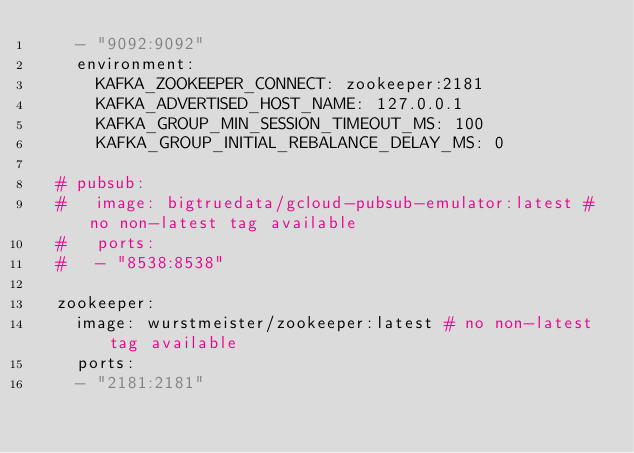Convert code to text. <code><loc_0><loc_0><loc_500><loc_500><_YAML_>    - "9092:9092"
    environment:
      KAFKA_ZOOKEEPER_CONNECT: zookeeper:2181
      KAFKA_ADVERTISED_HOST_NAME: 127.0.0.1
      KAFKA_GROUP_MIN_SESSION_TIMEOUT_MS: 100
      KAFKA_GROUP_INITIAL_REBALANCE_DELAY_MS: 0

  # pubsub:
  #   image: bigtruedata/gcloud-pubsub-emulator:latest # no non-latest tag available
  #   ports:
  #   - "8538:8538"

  zookeeper:
    image: wurstmeister/zookeeper:latest # no non-latest tag available
    ports:
    - "2181:2181"
</code> 